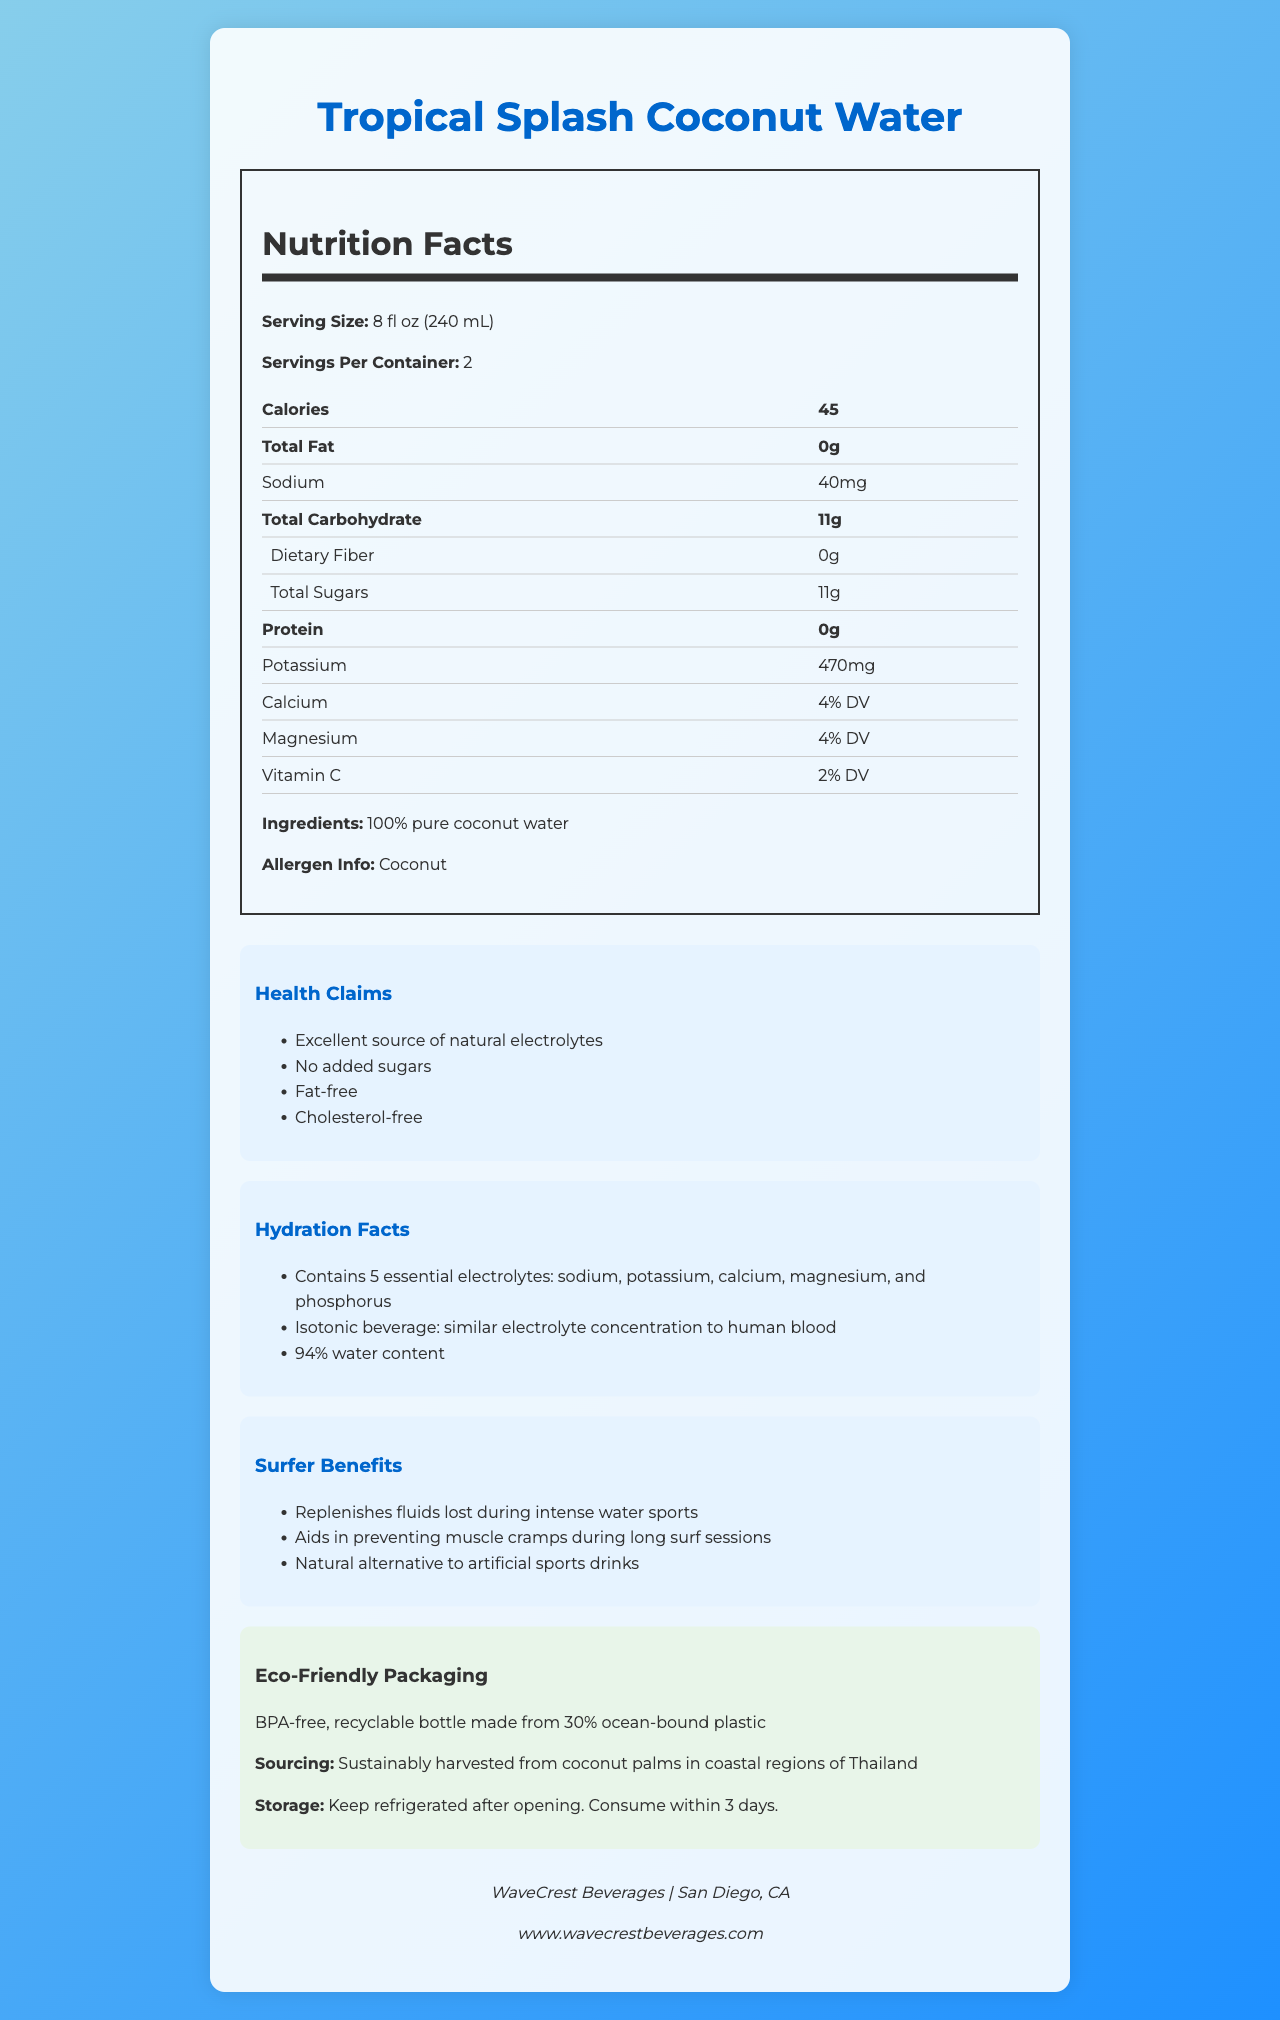How many calories are in one serving of Tropical Splash Coconut Water? The number of calories per serving is stated in the Nutrition Facts section under "Calories."
Answer: 45 What is the potassium content in one serving? The potassium content is listed in the Nutrition Facts section under "Potassium."
Answer: 470mg How many grams of total sugars are present per serving? The total amount of sugars per serving is listed under "Total Sugars" in the Nutrition Facts section.
Answer: 11g How many essential electrolytes does Tropical Splash Coconut Water contain? The Hydration Facts section mentions that the coconut water contains five essential electrolytes.
Answer: 5 According to the document, where is the coconut water sourced from? The sourcing information is mentioned in the Eco-Friendly Packaging section and states it is from coastal regions of Thailand.
Answer: Coastal regions of Thailand Does Tropical Splash Coconut Water have any added sugars? In the Health Claims section, it states "No added sugars."
Answer: No Which of the following is a health claim made by Tropical Splash Coconut Water? A. Contains artificial flavor B. Contains high fructose corn syrup C. Fat-free D. High in calories Option C, "Fat-free", is listed in the Health Claims section. The other options are not valid according to the document.
Answer: C What is the storage instruction after opening Tropical Splash Coconut Water? A. Keep in a dry place B. Store at room temperature C. Keep refrigerated D. Freeze The storage instructions state "Keep refrigerated after opening."
Answer: C Is Tropical Splash Coconut Water suitable for people with coconut allergies? In the Nutrition Facts section, it mentions that the product contains coconut, which is an allergen.
Answer: No Summarize the main purpose and key points of the document. The document details nutritional facts, health claims, hydration benefits, surfer benefits, sourcing information, eco-friendly packaging, storage instructions, and company info of Tropical Splash Coconut Water, emphasizing its advantages such as being fat-free, containing no added sugars, and providing essential electrolytes.
Answer: The document provides detailed information about Tropical Splash Coconut Water, indicating its nutritional value, hydration benefits, environmental friendliness, and suitability for athletes, particularly surfers. Key highlights include its high electrolyte content, natural source of hydration, sustainability, and appeal for intense water sports activities. Does the document provide the exact amount of Vitamin C in Tropical Splash Coconut Water? The document states Vitamin C content as "2% DV" but does not provide the exact amount in milligrams.
Answer: No What is the water content of the Tropical Splash Coconut Water? The Hydration Facts section states that the coconut water has a 94% water content.
Answer: 94% What percentage of calcium's daily value is provided in one serving? The Nutrition Facts section lists calcium as providing "4% DV."
Answer: 4% What advantage does Tropical Splash Coconut Water provide for surfers? The Surfer Benefits section mentions it helps replenish fluids lost during intense water sports.
Answer: Replenishes fluids lost during intense water sports List all the main nutrients found in Tropical Splash Coconut Water. These nutrients are listed in the Nutrition Facts section.
Answer: Calories, Total Fat, Sodium, Total Carbohydrate, Dietary Fiber, Total Sugars, Protein, Potassium, Calcium, Magnesium, Vitamin C What equipment did the company use for packaging Tropical Splash Coconut Water? The document mentions the packaging is BPA-free, recyclable, and made from 30% ocean-bound plastic but does not specify the equipment used for packaging.
Answer: Not enough information 